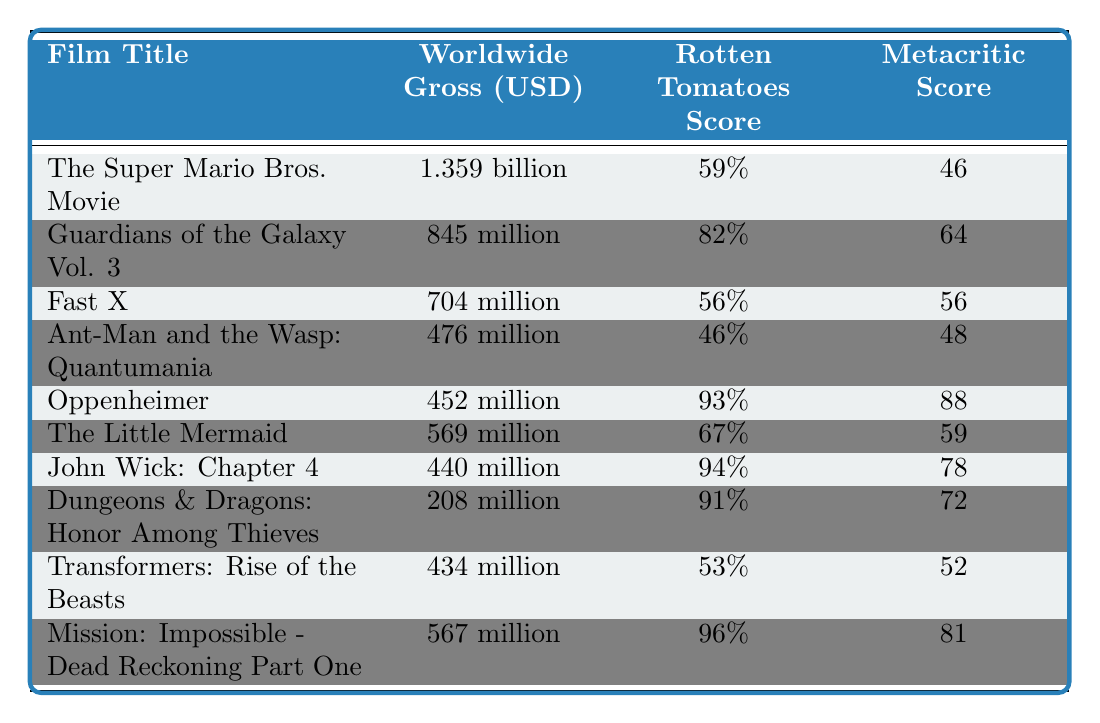What is the highest-grossing film on the list? The table displays the "Worldwide Gross (USD)" for each film. The highest figure is 1.359 billion for "The Super Mario Bros. Movie."
Answer: The Super Mario Bros. Movie Which film received a Rotten Tomatoes score of 96%? Looking at the "Rotten Tomatoes Score" column, "Mission: Impossible - Dead Reckoning Part One" has a score of 96%.
Answer: Mission: Impossible - Dead Reckoning Part One What is the total worldwide gross of the top three highest-grossing films? The top three films are "The Super Mario Bros. Movie" (1.359 billion), "Guardians of the Galaxy Vol. 3" (845 million), and "Fast X" (704 million). Summing these gives: 1.359 billion + 845 million + 704 million = 2.908 billion.
Answer: 2.908 billion Is there a film with a Rotten Tomatoes score below 50%? By reviewing the "Rotten Tomatoes Score" column, "Ant-Man and the Wasp: Quantumania" has a score of 46% which is below 50%.
Answer: Yes What is the average Metacritic score of the films listed? We can add the Metacritic scores: 46 + 64 + 56 + 48 + 88 + 59 + 78 + 72 + 52 + 81 = 570. There are 10 films, so the average is 570/10 = 57.
Answer: 57 Which film has the highest Metacritic score and what is that score? The "Metacritic Score" column shows the highest score is 96% for "Mission: Impossible - Dead Reckoning Part One."
Answer: Mission: Impossible - Dead Reckoning Part One, 96 How many films have both a Rotten Tomatoes score above 80% and a worldwide gross above 500 million? Filtering the table, "Guardians of the Galaxy Vol. 3" (82% & 845 million), "Oppenheimer" (93% & 452 million), "John Wick: Chapter 4" (94% & 440 million), and "Mission: Impossible - Dead Reckoning Part One" (96% & 567 million) qualify. Only "Guardians of the Galaxy Vol. 3" and "Mission: Impossible - Dead Reckoning Part One" meet both conditions, making it 2 films.
Answer: 2 Which film has the lowest worldwide gross, and what is that amount? The lowest figure in the "Worldwide Gross (USD)" column is 208 million for "Dungeons & Dragons: Honor Among Thieves."
Answer: Dungeons & Dragons: Honor Among Thieves, 208 million Are there any films with a Metacritic score higher than 80%? Checking the "Metacritic Score" column, "Oppenheimer" (88), "John Wick: Chapter 4" (78), "Dungeons & Dragons: Honor Among Thieves" (72), and "Mission: Impossible - Dead Reckoning Part One" (81) are scores higher than 80%. Thus, there are several films with scores above 80%.
Answer: Yes What is the difference in worldwide gross between the highest-grossing and the lowest-grossing films? The highest-grossing film, "The Super Mario Bros. Movie," grossed 1.359 billion, while the lowest, "Dungeons & Dragons: Honor Among Thieves," grossed 208 million. The difference is 1.359 billion - 208 million = 1.151 billion.
Answer: 1.151 billion 